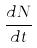<formula> <loc_0><loc_0><loc_500><loc_500>\frac { d N } { d t }</formula> 